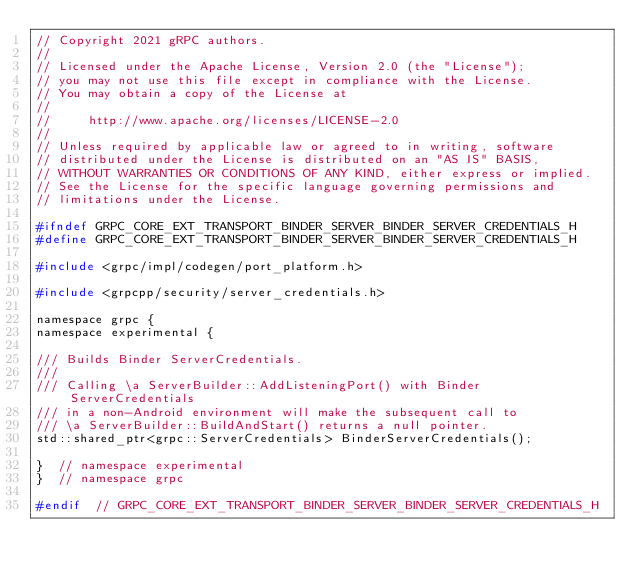<code> <loc_0><loc_0><loc_500><loc_500><_C_>// Copyright 2021 gRPC authors.
//
// Licensed under the Apache License, Version 2.0 (the "License");
// you may not use this file except in compliance with the License.
// You may obtain a copy of the License at
//
//     http://www.apache.org/licenses/LICENSE-2.0
//
// Unless required by applicable law or agreed to in writing, software
// distributed under the License is distributed on an "AS IS" BASIS,
// WITHOUT WARRANTIES OR CONDITIONS OF ANY KIND, either express or implied.
// See the License for the specific language governing permissions and
// limitations under the License.

#ifndef GRPC_CORE_EXT_TRANSPORT_BINDER_SERVER_BINDER_SERVER_CREDENTIALS_H
#define GRPC_CORE_EXT_TRANSPORT_BINDER_SERVER_BINDER_SERVER_CREDENTIALS_H

#include <grpc/impl/codegen/port_platform.h>

#include <grpcpp/security/server_credentials.h>

namespace grpc {
namespace experimental {

/// Builds Binder ServerCredentials.
///
/// Calling \a ServerBuilder::AddListeningPort() with Binder ServerCredentials
/// in a non-Android environment will make the subsequent call to
/// \a ServerBuilder::BuildAndStart() returns a null pointer.
std::shared_ptr<grpc::ServerCredentials> BinderServerCredentials();

}  // namespace experimental
}  // namespace grpc

#endif  // GRPC_CORE_EXT_TRANSPORT_BINDER_SERVER_BINDER_SERVER_CREDENTIALS_H
</code> 